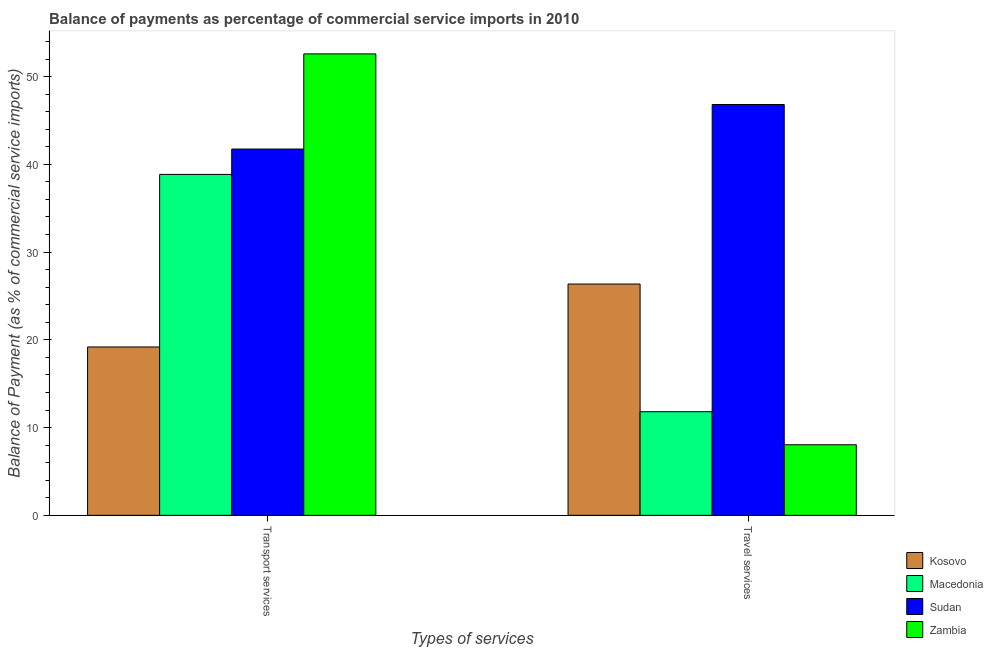How many different coloured bars are there?
Your response must be concise. 4. Are the number of bars on each tick of the X-axis equal?
Give a very brief answer. Yes. How many bars are there on the 2nd tick from the right?
Provide a succinct answer. 4. What is the label of the 1st group of bars from the left?
Your answer should be compact. Transport services. What is the balance of payments of travel services in Zambia?
Your answer should be very brief. 8.04. Across all countries, what is the maximum balance of payments of travel services?
Provide a short and direct response. 46.82. Across all countries, what is the minimum balance of payments of transport services?
Provide a short and direct response. 19.19. In which country was the balance of payments of travel services maximum?
Provide a succinct answer. Sudan. In which country was the balance of payments of transport services minimum?
Your answer should be compact. Kosovo. What is the total balance of payments of travel services in the graph?
Your answer should be very brief. 93.03. What is the difference between the balance of payments of transport services in Sudan and that in Kosovo?
Provide a succinct answer. 22.55. What is the difference between the balance of payments of transport services in Sudan and the balance of payments of travel services in Kosovo?
Your answer should be very brief. 15.38. What is the average balance of payments of travel services per country?
Provide a succinct answer. 23.26. What is the difference between the balance of payments of travel services and balance of payments of transport services in Zambia?
Provide a succinct answer. -44.54. What is the ratio of the balance of payments of transport services in Zambia to that in Sudan?
Your answer should be very brief. 1.26. In how many countries, is the balance of payments of transport services greater than the average balance of payments of transport services taken over all countries?
Offer a terse response. 3. What does the 4th bar from the left in Travel services represents?
Give a very brief answer. Zambia. What does the 1st bar from the right in Travel services represents?
Give a very brief answer. Zambia. Are all the bars in the graph horizontal?
Offer a terse response. No. How many countries are there in the graph?
Your response must be concise. 4. Does the graph contain any zero values?
Your response must be concise. No. Where does the legend appear in the graph?
Ensure brevity in your answer.  Bottom right. What is the title of the graph?
Ensure brevity in your answer.  Balance of payments as percentage of commercial service imports in 2010. What is the label or title of the X-axis?
Make the answer very short. Types of services. What is the label or title of the Y-axis?
Offer a very short reply. Balance of Payment (as % of commercial service imports). What is the Balance of Payment (as % of commercial service imports) of Kosovo in Transport services?
Offer a very short reply. 19.19. What is the Balance of Payment (as % of commercial service imports) of Macedonia in Transport services?
Give a very brief answer. 38.85. What is the Balance of Payment (as % of commercial service imports) in Sudan in Transport services?
Provide a short and direct response. 41.74. What is the Balance of Payment (as % of commercial service imports) of Zambia in Transport services?
Give a very brief answer. 52.59. What is the Balance of Payment (as % of commercial service imports) of Kosovo in Travel services?
Provide a short and direct response. 26.36. What is the Balance of Payment (as % of commercial service imports) of Macedonia in Travel services?
Ensure brevity in your answer.  11.81. What is the Balance of Payment (as % of commercial service imports) in Sudan in Travel services?
Offer a very short reply. 46.82. What is the Balance of Payment (as % of commercial service imports) of Zambia in Travel services?
Offer a terse response. 8.04. Across all Types of services, what is the maximum Balance of Payment (as % of commercial service imports) in Kosovo?
Offer a very short reply. 26.36. Across all Types of services, what is the maximum Balance of Payment (as % of commercial service imports) of Macedonia?
Your answer should be compact. 38.85. Across all Types of services, what is the maximum Balance of Payment (as % of commercial service imports) in Sudan?
Offer a very short reply. 46.82. Across all Types of services, what is the maximum Balance of Payment (as % of commercial service imports) in Zambia?
Keep it short and to the point. 52.59. Across all Types of services, what is the minimum Balance of Payment (as % of commercial service imports) in Kosovo?
Your answer should be compact. 19.19. Across all Types of services, what is the minimum Balance of Payment (as % of commercial service imports) of Macedonia?
Make the answer very short. 11.81. Across all Types of services, what is the minimum Balance of Payment (as % of commercial service imports) of Sudan?
Give a very brief answer. 41.74. Across all Types of services, what is the minimum Balance of Payment (as % of commercial service imports) in Zambia?
Ensure brevity in your answer.  8.04. What is the total Balance of Payment (as % of commercial service imports) in Kosovo in the graph?
Your response must be concise. 45.55. What is the total Balance of Payment (as % of commercial service imports) in Macedonia in the graph?
Your response must be concise. 50.66. What is the total Balance of Payment (as % of commercial service imports) of Sudan in the graph?
Offer a terse response. 88.56. What is the total Balance of Payment (as % of commercial service imports) in Zambia in the graph?
Give a very brief answer. 60.63. What is the difference between the Balance of Payment (as % of commercial service imports) in Kosovo in Transport services and that in Travel services?
Make the answer very short. -7.17. What is the difference between the Balance of Payment (as % of commercial service imports) in Macedonia in Transport services and that in Travel services?
Your answer should be very brief. 27.04. What is the difference between the Balance of Payment (as % of commercial service imports) of Sudan in Transport services and that in Travel services?
Provide a short and direct response. -5.08. What is the difference between the Balance of Payment (as % of commercial service imports) of Zambia in Transport services and that in Travel services?
Your response must be concise. 44.54. What is the difference between the Balance of Payment (as % of commercial service imports) in Kosovo in Transport services and the Balance of Payment (as % of commercial service imports) in Macedonia in Travel services?
Your answer should be compact. 7.38. What is the difference between the Balance of Payment (as % of commercial service imports) in Kosovo in Transport services and the Balance of Payment (as % of commercial service imports) in Sudan in Travel services?
Your answer should be compact. -27.63. What is the difference between the Balance of Payment (as % of commercial service imports) in Kosovo in Transport services and the Balance of Payment (as % of commercial service imports) in Zambia in Travel services?
Provide a short and direct response. 11.15. What is the difference between the Balance of Payment (as % of commercial service imports) of Macedonia in Transport services and the Balance of Payment (as % of commercial service imports) of Sudan in Travel services?
Your response must be concise. -7.97. What is the difference between the Balance of Payment (as % of commercial service imports) of Macedonia in Transport services and the Balance of Payment (as % of commercial service imports) of Zambia in Travel services?
Provide a succinct answer. 30.81. What is the difference between the Balance of Payment (as % of commercial service imports) in Sudan in Transport services and the Balance of Payment (as % of commercial service imports) in Zambia in Travel services?
Provide a short and direct response. 33.7. What is the average Balance of Payment (as % of commercial service imports) in Kosovo per Types of services?
Your answer should be very brief. 22.77. What is the average Balance of Payment (as % of commercial service imports) in Macedonia per Types of services?
Your answer should be very brief. 25.33. What is the average Balance of Payment (as % of commercial service imports) of Sudan per Types of services?
Your answer should be compact. 44.28. What is the average Balance of Payment (as % of commercial service imports) in Zambia per Types of services?
Offer a very short reply. 30.31. What is the difference between the Balance of Payment (as % of commercial service imports) of Kosovo and Balance of Payment (as % of commercial service imports) of Macedonia in Transport services?
Provide a short and direct response. -19.66. What is the difference between the Balance of Payment (as % of commercial service imports) in Kosovo and Balance of Payment (as % of commercial service imports) in Sudan in Transport services?
Keep it short and to the point. -22.55. What is the difference between the Balance of Payment (as % of commercial service imports) of Kosovo and Balance of Payment (as % of commercial service imports) of Zambia in Transport services?
Give a very brief answer. -33.4. What is the difference between the Balance of Payment (as % of commercial service imports) of Macedonia and Balance of Payment (as % of commercial service imports) of Sudan in Transport services?
Make the answer very short. -2.89. What is the difference between the Balance of Payment (as % of commercial service imports) in Macedonia and Balance of Payment (as % of commercial service imports) in Zambia in Transport services?
Offer a very short reply. -13.73. What is the difference between the Balance of Payment (as % of commercial service imports) of Sudan and Balance of Payment (as % of commercial service imports) of Zambia in Transport services?
Make the answer very short. -10.84. What is the difference between the Balance of Payment (as % of commercial service imports) of Kosovo and Balance of Payment (as % of commercial service imports) of Macedonia in Travel services?
Provide a short and direct response. 14.55. What is the difference between the Balance of Payment (as % of commercial service imports) in Kosovo and Balance of Payment (as % of commercial service imports) in Sudan in Travel services?
Your answer should be compact. -20.46. What is the difference between the Balance of Payment (as % of commercial service imports) of Kosovo and Balance of Payment (as % of commercial service imports) of Zambia in Travel services?
Provide a short and direct response. 18.32. What is the difference between the Balance of Payment (as % of commercial service imports) in Macedonia and Balance of Payment (as % of commercial service imports) in Sudan in Travel services?
Offer a very short reply. -35.01. What is the difference between the Balance of Payment (as % of commercial service imports) in Macedonia and Balance of Payment (as % of commercial service imports) in Zambia in Travel services?
Offer a terse response. 3.77. What is the difference between the Balance of Payment (as % of commercial service imports) of Sudan and Balance of Payment (as % of commercial service imports) of Zambia in Travel services?
Keep it short and to the point. 38.78. What is the ratio of the Balance of Payment (as % of commercial service imports) of Kosovo in Transport services to that in Travel services?
Your answer should be very brief. 0.73. What is the ratio of the Balance of Payment (as % of commercial service imports) of Macedonia in Transport services to that in Travel services?
Your response must be concise. 3.29. What is the ratio of the Balance of Payment (as % of commercial service imports) in Sudan in Transport services to that in Travel services?
Your response must be concise. 0.89. What is the ratio of the Balance of Payment (as % of commercial service imports) of Zambia in Transport services to that in Travel services?
Make the answer very short. 6.54. What is the difference between the highest and the second highest Balance of Payment (as % of commercial service imports) of Kosovo?
Your response must be concise. 7.17. What is the difference between the highest and the second highest Balance of Payment (as % of commercial service imports) of Macedonia?
Give a very brief answer. 27.04. What is the difference between the highest and the second highest Balance of Payment (as % of commercial service imports) in Sudan?
Provide a short and direct response. 5.08. What is the difference between the highest and the second highest Balance of Payment (as % of commercial service imports) in Zambia?
Your answer should be very brief. 44.54. What is the difference between the highest and the lowest Balance of Payment (as % of commercial service imports) in Kosovo?
Give a very brief answer. 7.17. What is the difference between the highest and the lowest Balance of Payment (as % of commercial service imports) of Macedonia?
Give a very brief answer. 27.04. What is the difference between the highest and the lowest Balance of Payment (as % of commercial service imports) of Sudan?
Provide a short and direct response. 5.08. What is the difference between the highest and the lowest Balance of Payment (as % of commercial service imports) in Zambia?
Ensure brevity in your answer.  44.54. 